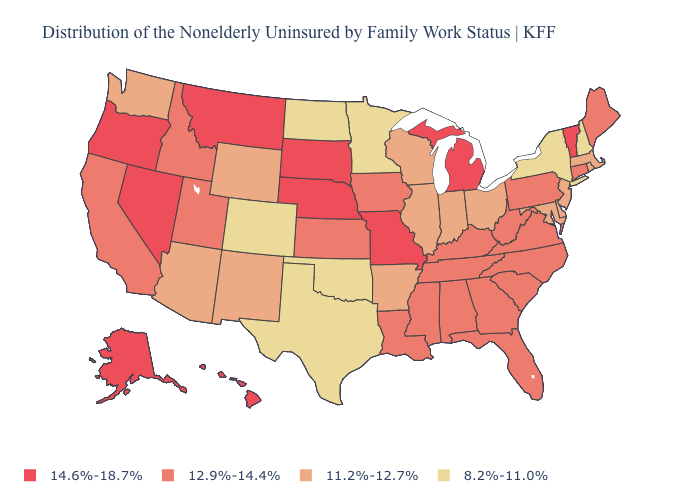Does Arizona have the same value as Massachusetts?
Be succinct. Yes. What is the value of Virginia?
Concise answer only. 12.9%-14.4%. What is the highest value in the West ?
Quick response, please. 14.6%-18.7%. What is the value of Maryland?
Concise answer only. 11.2%-12.7%. Is the legend a continuous bar?
Short answer required. No. What is the lowest value in states that border South Dakota?
Answer briefly. 8.2%-11.0%. What is the lowest value in the USA?
Give a very brief answer. 8.2%-11.0%. What is the value of Alabama?
Give a very brief answer. 12.9%-14.4%. What is the value of Georgia?
Answer briefly. 12.9%-14.4%. What is the highest value in the Northeast ?
Give a very brief answer. 14.6%-18.7%. Does New Mexico have a lower value than Alabama?
Give a very brief answer. Yes. What is the value of Maryland?
Be succinct. 11.2%-12.7%. What is the value of Arizona?
Concise answer only. 11.2%-12.7%. Name the states that have a value in the range 14.6%-18.7%?
Concise answer only. Alaska, Hawaii, Michigan, Missouri, Montana, Nebraska, Nevada, Oregon, South Dakota, Vermont. What is the value of Kansas?
Be succinct. 12.9%-14.4%. 